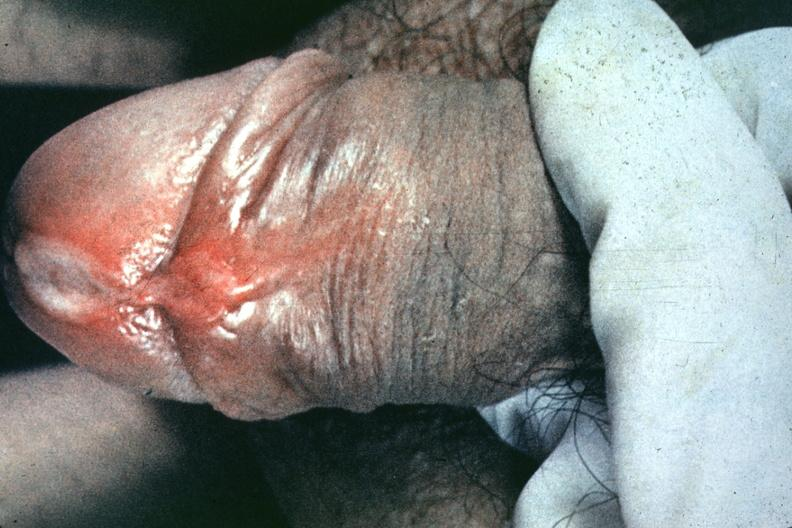s peritoneal fluid present?
Answer the question using a single word or phrase. No 